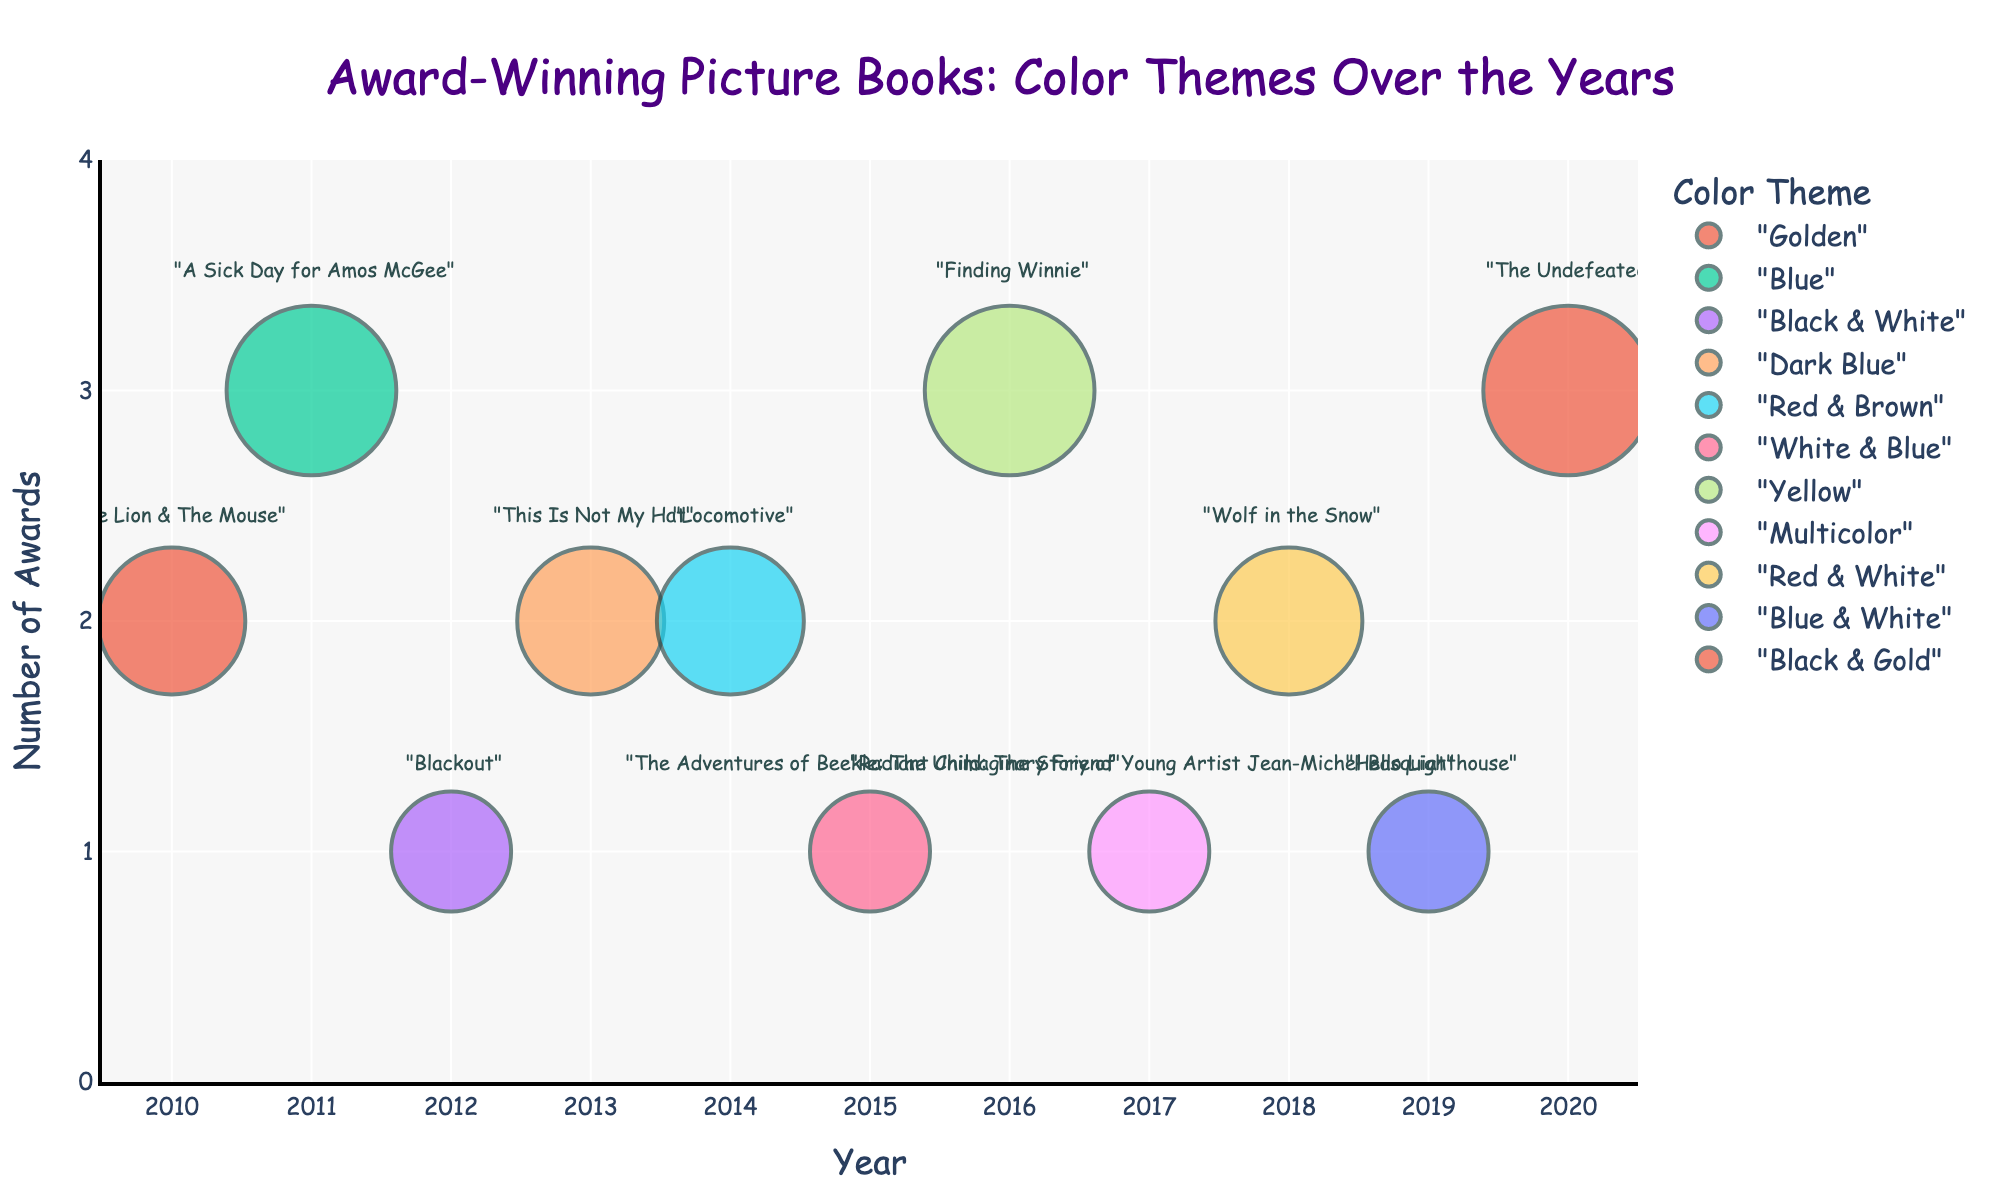How many books have a color theme that includes the color "Blue"? By looking at the colors: "Blue", "Dark Blue", "White & Blue", and "Blue & White", we can count those books as including "Blue".
Answer: 4 What is the title of the book with the highest number of awards? The bubble chart shows that the book with the highest number of awards (3) is either "A Sick Day for Amos McGee", "Finding Winnie", or "The Undefeated".
Answer: "A Sick Day for Amos McGee", "Finding Winnie", "The Undefeated" Which year had the book with the smallest bubble size? By comparing the bubble sizes, the smallest bubbles are in the years 2012, 2015, 2017, and 2019.
Answer: 2012, 2015, 2017, 2019 Is there any year when two books with different color themes won the same number of awards? Looking at the years where multiple books have a bubble, we see 2010, 2013, 2014, and 2018 each having two different color-themed books winning the same number of awards.
Answer: 2010, 2013, 2014, 2018 Which book has a multicolor theme? By finding the bubble with the "Multicolor" category, we see it's "Radiant Child: The Story of Young Artist Jean-Michel Basquiat" in 2017.
Answer: "Radiant Child: The Story of Young Artist Jean-Michel Basquiat" How many books have won three awards? Checking for the bubbles that correspond to "Number of Awards" = 3, we identify three such bubbles.
Answer: 3 Which year had the most award-winning books represented in the bubble chart? By counting the number of bubbles per year, we see that 2010, 2013, 2014, and 2018 each have two books represented.
Answer: 2010, 2013, 2014, 2018 What is the average number of awards per book in 2016? Since there is only one book in 2016, the number of awards is simply 3, and the average is 3.
Answer: 3 Which book had the darkest color theme and how many awards did it win? "This Is Not My Hat" features a "Dark Blue" theme and has 2 awards.
Answer: "This Is Not My Hat", 2 What is the total number of awards for books with the color theme including "White" in 2018 and 2019? The books "Wolf in the Snow" (2 awards) and "Hello Lighthouse" (1 award) have themes including "White". Adding 2 and 1 gives the total awards.
Answer: 3 